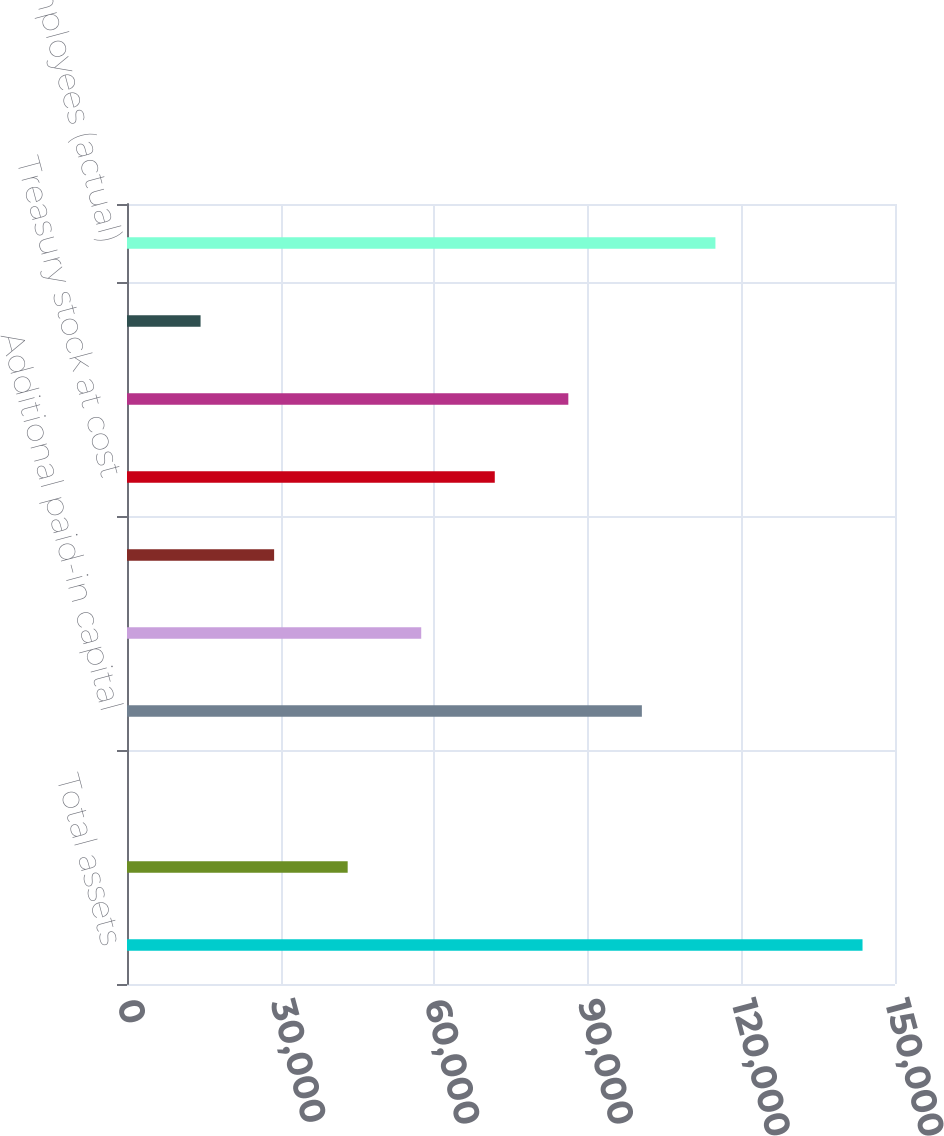<chart> <loc_0><loc_0><loc_500><loc_500><bar_chart><fcel>Total assets<fcel>Long-term debt<fcel>Common stock<fcel>Additional paid-in capital<fcel>Retained earnings<fcel>Accumulated other<fcel>Treasury stock at cost<fcel>Total stockholders' equity<fcel>AUM ( in billions)<fcel>Number of employees (actual)<nl><fcel>143658<fcel>43100.1<fcel>3.8<fcel>100562<fcel>57465.5<fcel>28734.7<fcel>71830.9<fcel>86196.4<fcel>14369.2<fcel>114927<nl></chart> 